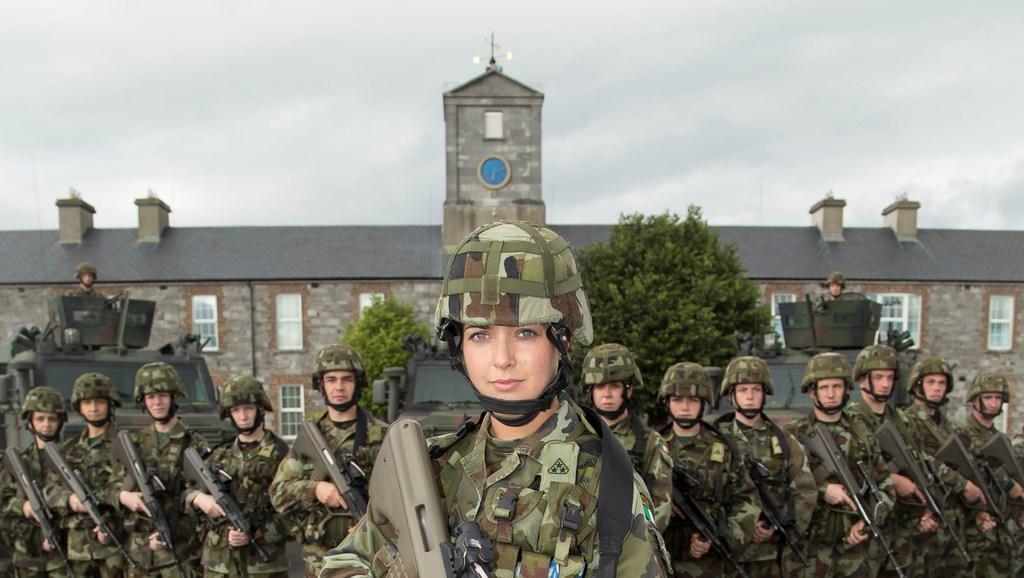Describe this image in one or two sentences. In this image I see number of people in which all of them are wearing army uniforms and these 2 persons are on the tanks and I see that these persons are holding guns in their hands. In the background I see the trees, a building on which there is a clock over here and I see the sky. 